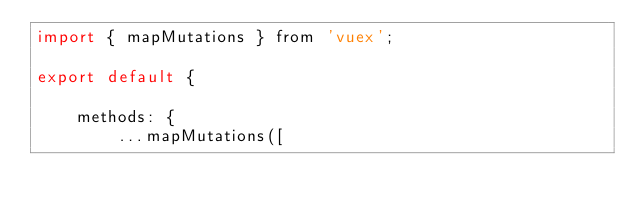Convert code to text. <code><loc_0><loc_0><loc_500><loc_500><_JavaScript_>import { mapMutations } from 'vuex';

export default {

	methods: {
		...mapMutations([</code> 